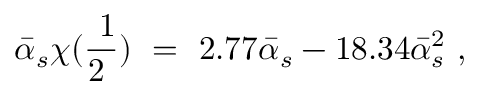<formula> <loc_0><loc_0><loc_500><loc_500>\bar { \alpha } _ { s } \chi ( \frac { 1 } { 2 } ) \ = \ 2 . 7 7 \bar { \alpha } _ { s } - 1 8 . 3 4 \bar { \alpha } _ { s } ^ { 2 } \ ,</formula> 